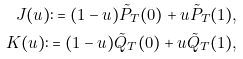Convert formula to latex. <formula><loc_0><loc_0><loc_500><loc_500>J ( u ) \colon = ( 1 - u ) \tilde { P } _ { T } ( 0 ) + u \tilde { P } _ { T } ( 1 ) , \\ K ( u ) \colon = ( 1 - u ) \tilde { Q } _ { T } ( 0 ) + u \tilde { Q } _ { T } ( 1 ) ,</formula> 